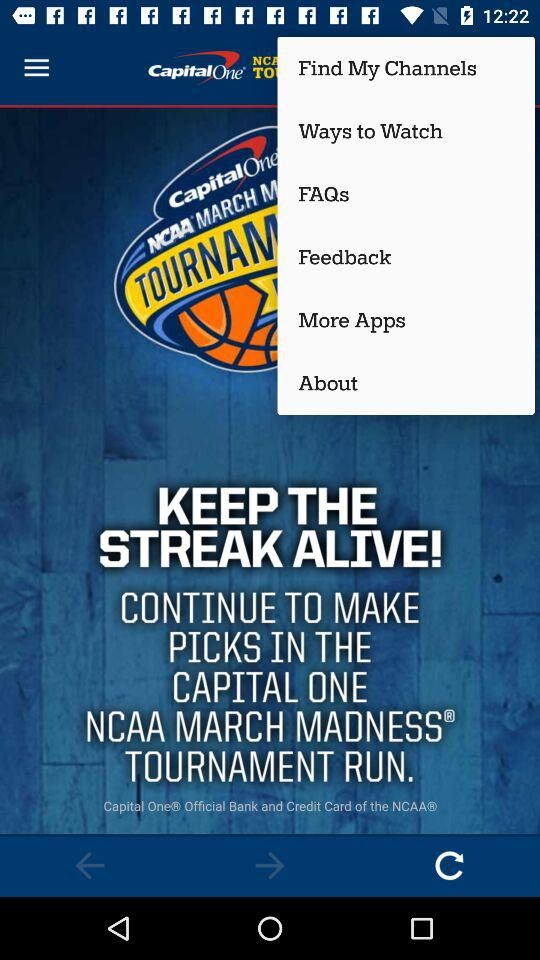How many new FAQs are there?
When the provided information is insufficient, respond with <no answer>. <no answer> 